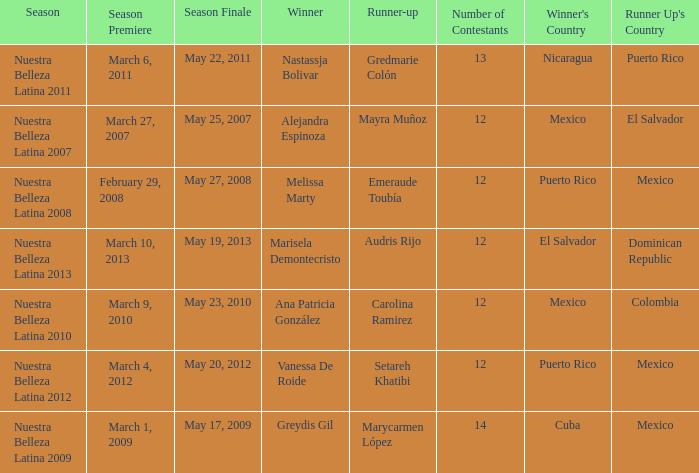What season had more than 12 contestants in which greydis gil won? Nuestra Belleza Latina 2009. 